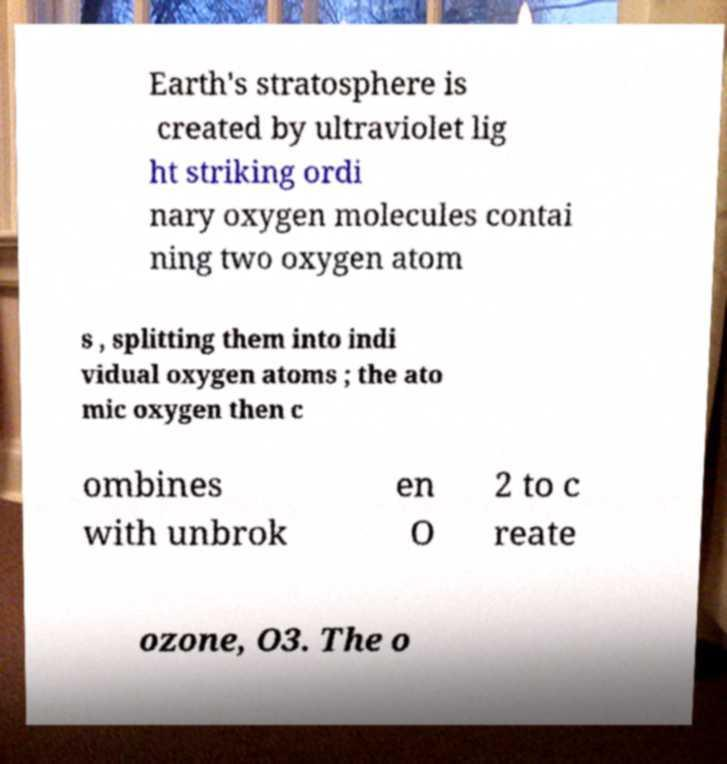Can you accurately transcribe the text from the provided image for me? Earth's stratosphere is created by ultraviolet lig ht striking ordi nary oxygen molecules contai ning two oxygen atom s , splitting them into indi vidual oxygen atoms ; the ato mic oxygen then c ombines with unbrok en O 2 to c reate ozone, O3. The o 